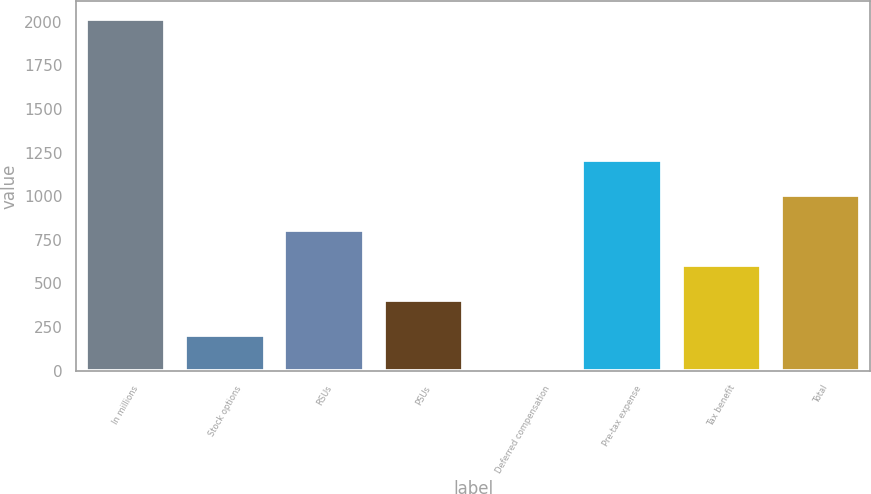Convert chart to OTSL. <chart><loc_0><loc_0><loc_500><loc_500><bar_chart><fcel>In millions<fcel>Stock options<fcel>RSUs<fcel>PSUs<fcel>Deferred compensation<fcel>Pre-tax expense<fcel>Tax benefit<fcel>Total<nl><fcel>2016<fcel>202.32<fcel>806.88<fcel>403.84<fcel>0.8<fcel>1209.92<fcel>605.36<fcel>1008.4<nl></chart> 